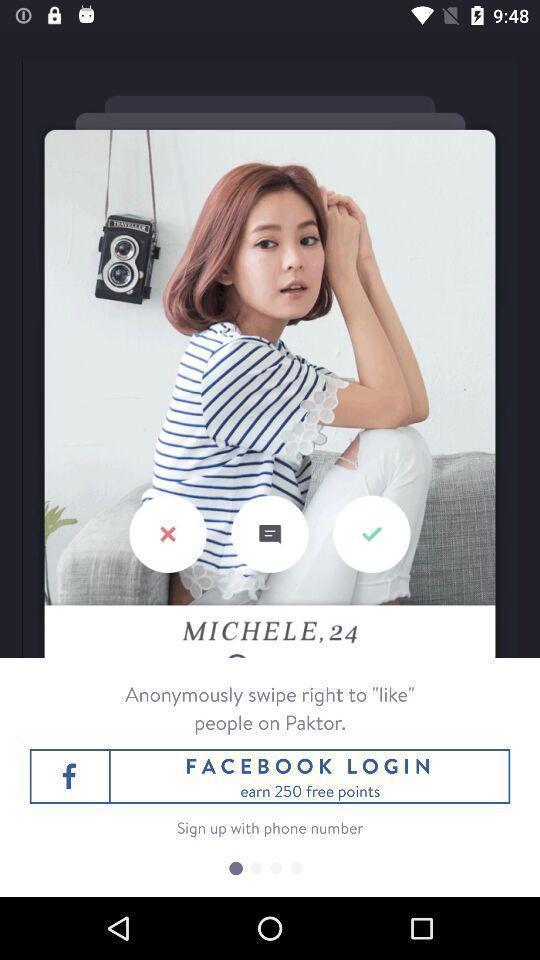Explain what's happening in this screen capture. Page displaying to login into a dating app. 